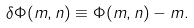Convert formula to latex. <formula><loc_0><loc_0><loc_500><loc_500>\delta \Phi ( m , n ) \equiv \Phi ( m , n ) - m .</formula> 